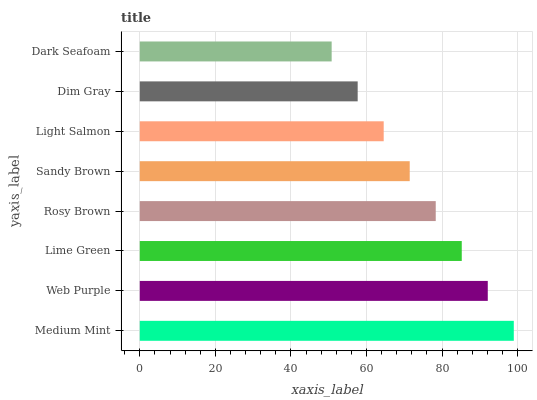Is Dark Seafoam the minimum?
Answer yes or no. Yes. Is Medium Mint the maximum?
Answer yes or no. Yes. Is Web Purple the minimum?
Answer yes or no. No. Is Web Purple the maximum?
Answer yes or no. No. Is Medium Mint greater than Web Purple?
Answer yes or no. Yes. Is Web Purple less than Medium Mint?
Answer yes or no. Yes. Is Web Purple greater than Medium Mint?
Answer yes or no. No. Is Medium Mint less than Web Purple?
Answer yes or no. No. Is Rosy Brown the high median?
Answer yes or no. Yes. Is Sandy Brown the low median?
Answer yes or no. Yes. Is Dim Gray the high median?
Answer yes or no. No. Is Dim Gray the low median?
Answer yes or no. No. 